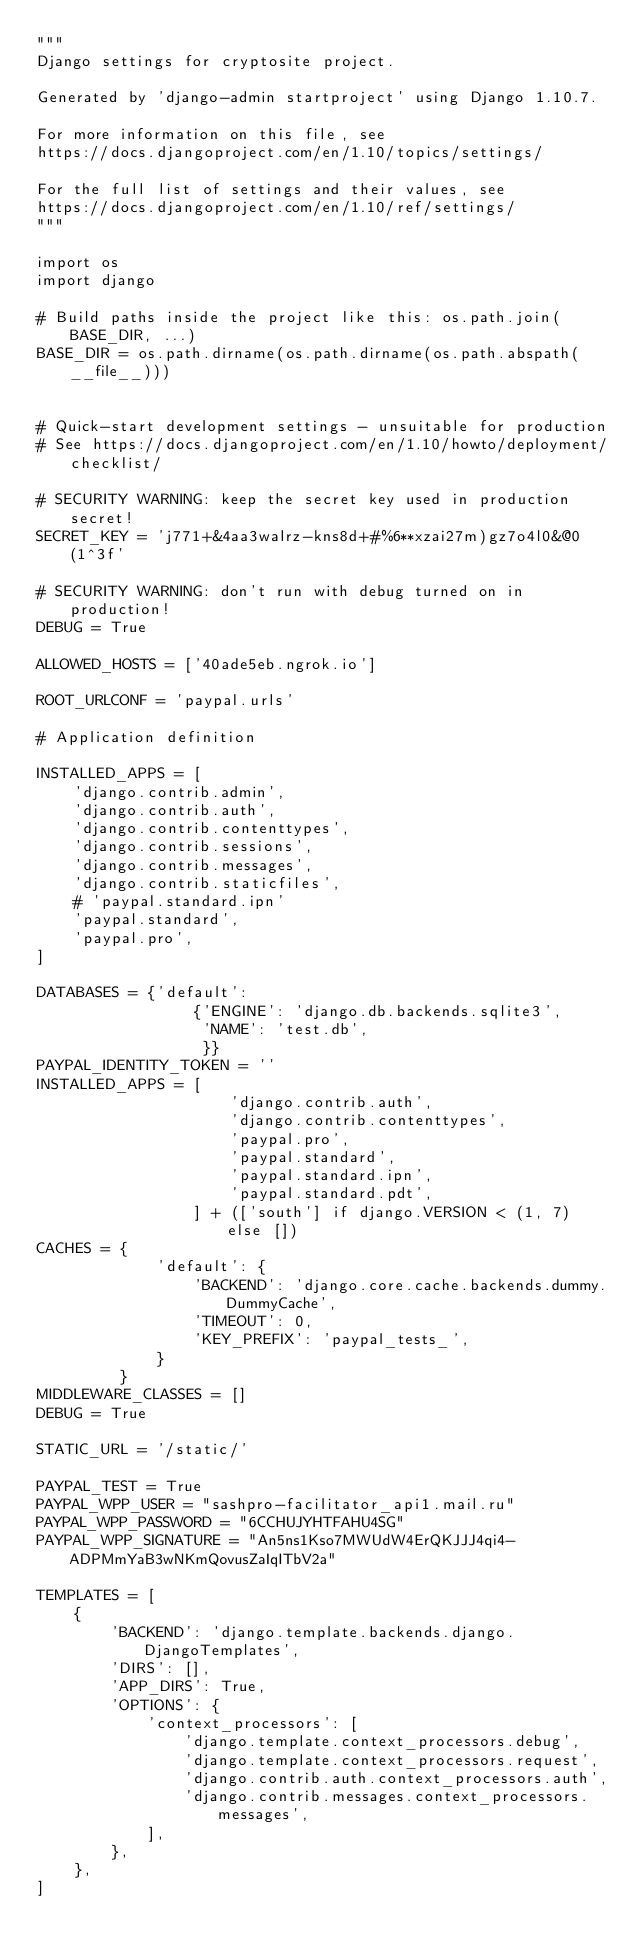Convert code to text. <code><loc_0><loc_0><loc_500><loc_500><_Python_>"""
Django settings for cryptosite project.

Generated by 'django-admin startproject' using Django 1.10.7.

For more information on this file, see
https://docs.djangoproject.com/en/1.10/topics/settings/

For the full list of settings and their values, see
https://docs.djangoproject.com/en/1.10/ref/settings/
"""

import os
import django

# Build paths inside the project like this: os.path.join(BASE_DIR, ...)
BASE_DIR = os.path.dirname(os.path.dirname(os.path.abspath(__file__)))


# Quick-start development settings - unsuitable for production
# See https://docs.djangoproject.com/en/1.10/howto/deployment/checklist/

# SECURITY WARNING: keep the secret key used in production secret!
SECRET_KEY = 'j771+&4aa3walrz-kns8d+#%6**xzai27m)gz7o4l0&@0(1^3f'

# SECURITY WARNING: don't run with debug turned on in production!
DEBUG = True

ALLOWED_HOSTS = ['40ade5eb.ngrok.io']

ROOT_URLCONF = 'paypal.urls'

# Application definition

INSTALLED_APPS = [
    'django.contrib.admin',
    'django.contrib.auth',
    'django.contrib.contenttypes',
    'django.contrib.sessions',
    'django.contrib.messages',
    'django.contrib.staticfiles',
    # 'paypal.standard.ipn'
    'paypal.standard',
    'paypal.pro',
]

DATABASES = {'default':
                 {'ENGINE': 'django.db.backends.sqlite3',
                  'NAME': 'test.db',
                  }}
PAYPAL_IDENTITY_TOKEN = ''
INSTALLED_APPS = [
                     'django.contrib.auth',
                     'django.contrib.contenttypes',
                     'paypal.pro',
                     'paypal.standard',
                     'paypal.standard.ipn',
                     'paypal.standard.pdt',
                 ] + (['south'] if django.VERSION < (1, 7) else [])
CACHES = {
             'default': {
                 'BACKEND': 'django.core.cache.backends.dummy.DummyCache',
                 'TIMEOUT': 0,
                 'KEY_PREFIX': 'paypal_tests_',
             }
         }
MIDDLEWARE_CLASSES = []
DEBUG = True

STATIC_URL = '/static/'

PAYPAL_TEST = True
PAYPAL_WPP_USER = "sashpro-facilitator_api1.mail.ru"
PAYPAL_WPP_PASSWORD = "6CCHUJYHTFAHU4SG"
PAYPAL_WPP_SIGNATURE = "An5ns1Kso7MWUdW4ErQKJJJ4qi4-ADPMmYaB3wNKmQovusZaIqITbV2a"

TEMPLATES = [
    {
        'BACKEND': 'django.template.backends.django.DjangoTemplates',
        'DIRS': [],
        'APP_DIRS': True,
        'OPTIONS': {
            'context_processors': [
                'django.template.context_processors.debug',
                'django.template.context_processors.request',
                'django.contrib.auth.context_processors.auth',
                'django.contrib.messages.context_processors.messages',
            ],
        },
    },
]</code> 